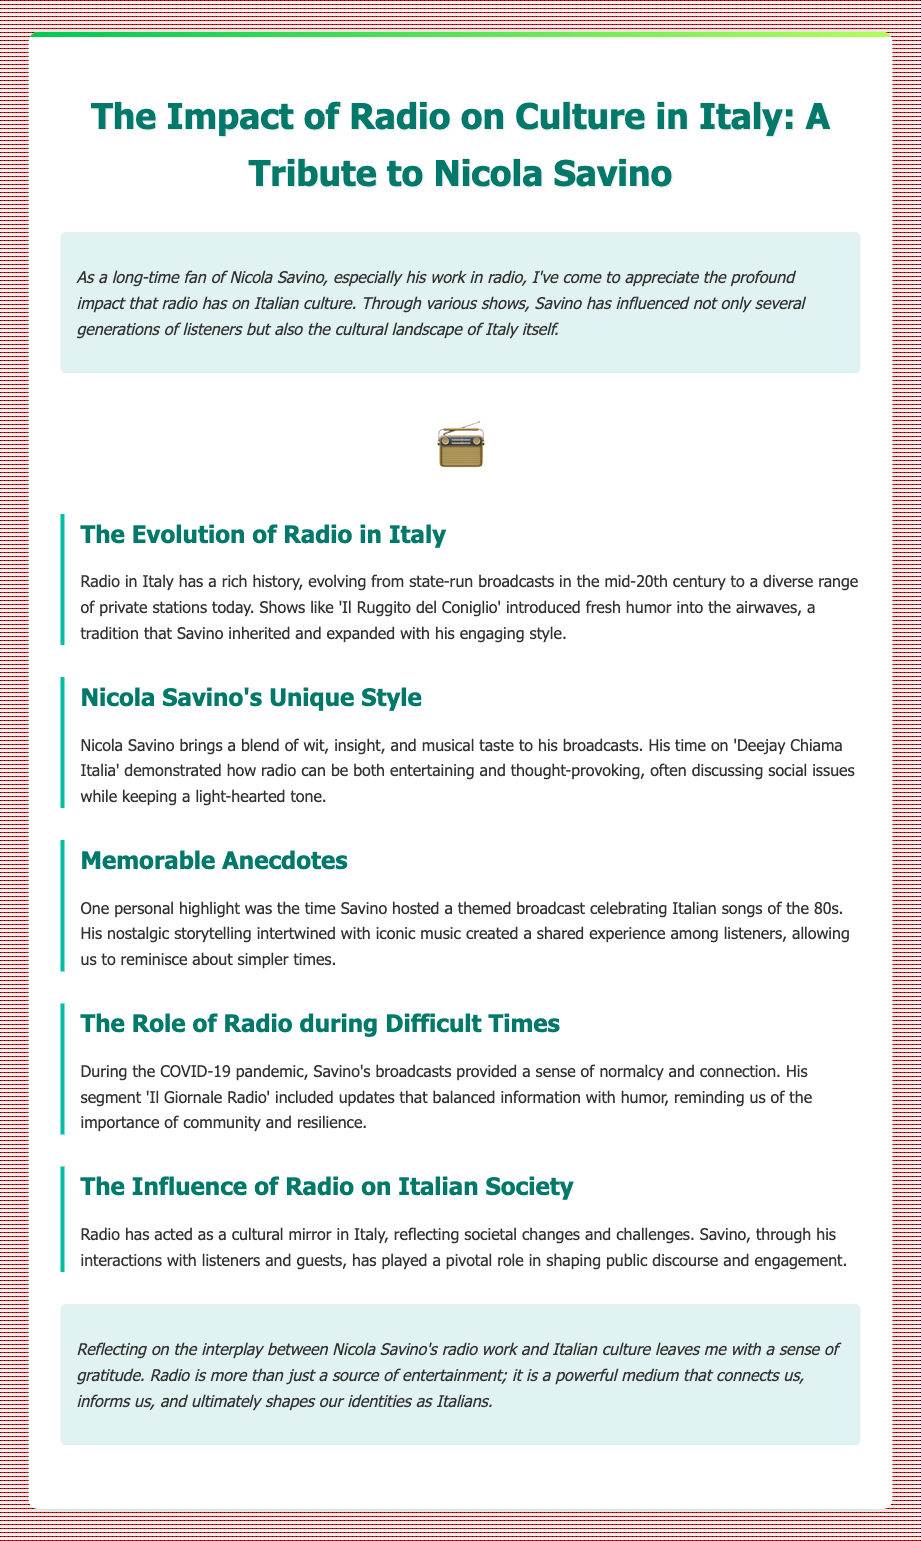What is the main subject of the note? The note primarily discusses the impact of radio on Italian culture, particularly through the lens of Nicola Savino's work.
Answer: Impact of radio on culture in Italy Which radio show is specifically mentioned in relation to Nicola Savino? 'Deejay Chiama Italia' is highlighted as a significant show during Savino's career.
Answer: Deejay Chiama Italia What did Nicola Savino celebrate in a memorable broadcast? He hosted a themed broadcast celebrating Italian songs of the 80s.
Answer: Italian songs of the 80s During which event did Savino's broadcasts provide a sense of normalcy? His broadcasts offered comfort during the COVID-19 pandemic.
Answer: COVID-19 pandemic What does the author express towards the end of the note? The author conveys a sense of gratitude for the influence of radio and Savino's contributions.
Answer: Gratitude What type of broadcasting style does Nicola Savino have? Savino is described as having a blend of wit, insight, and musical taste.
Answer: Wit, insight, and musical taste What aspect of radio does the note emphasize regarding its role in Italian society? The note emphasizes that radio reflects societal changes and challenges.
Answer: Reflects societal changes and challenges What personal experience does the author share? The author recalls reminiscing about simpler times during Savino's 80s music broadcast.
Answer: Nostalgic storytelling with 80s music 